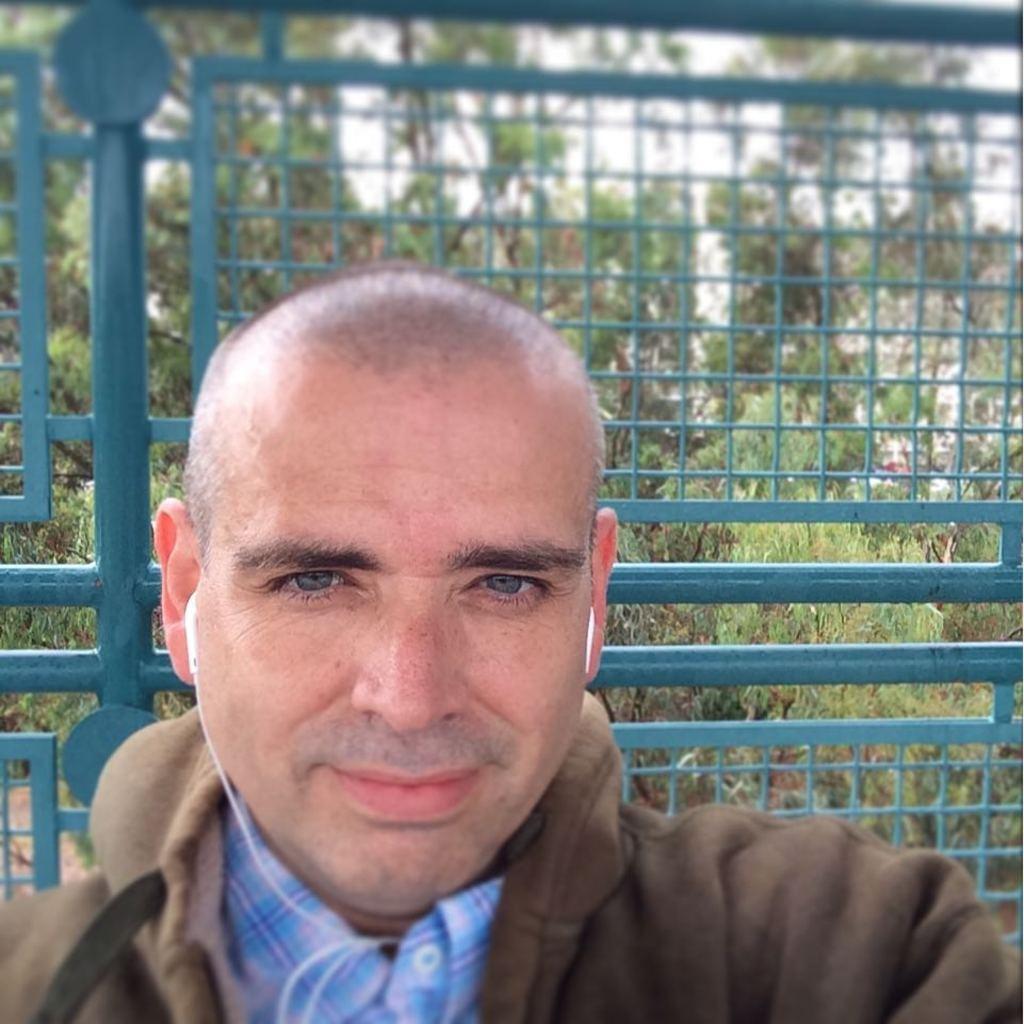Describe this image in one or two sentences. In this image we can see a man. On the backside we can see a metal fence, a group of trees and the sky. 